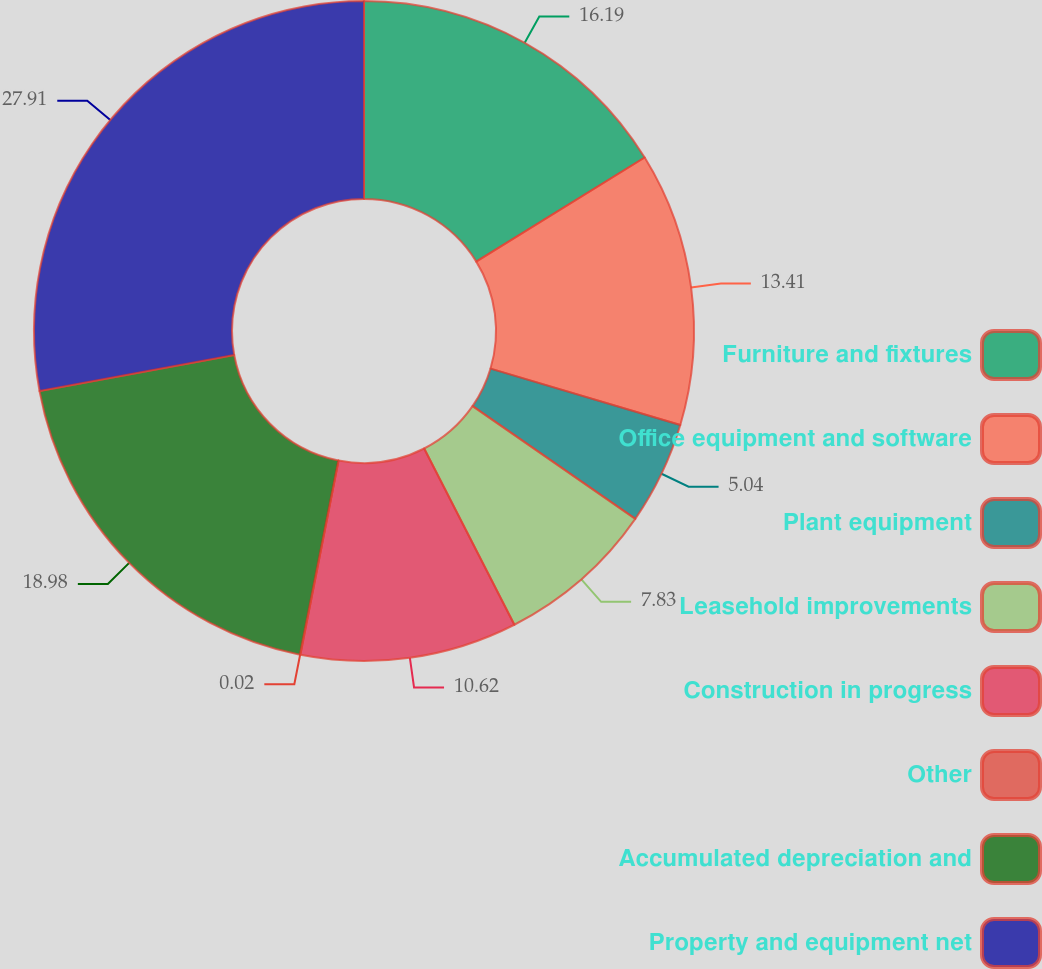Convert chart. <chart><loc_0><loc_0><loc_500><loc_500><pie_chart><fcel>Furniture and fixtures<fcel>Office equipment and software<fcel>Plant equipment<fcel>Leasehold improvements<fcel>Construction in progress<fcel>Other<fcel>Accumulated depreciation and<fcel>Property and equipment net<nl><fcel>16.19%<fcel>13.41%<fcel>5.04%<fcel>7.83%<fcel>10.62%<fcel>0.02%<fcel>18.98%<fcel>27.91%<nl></chart> 